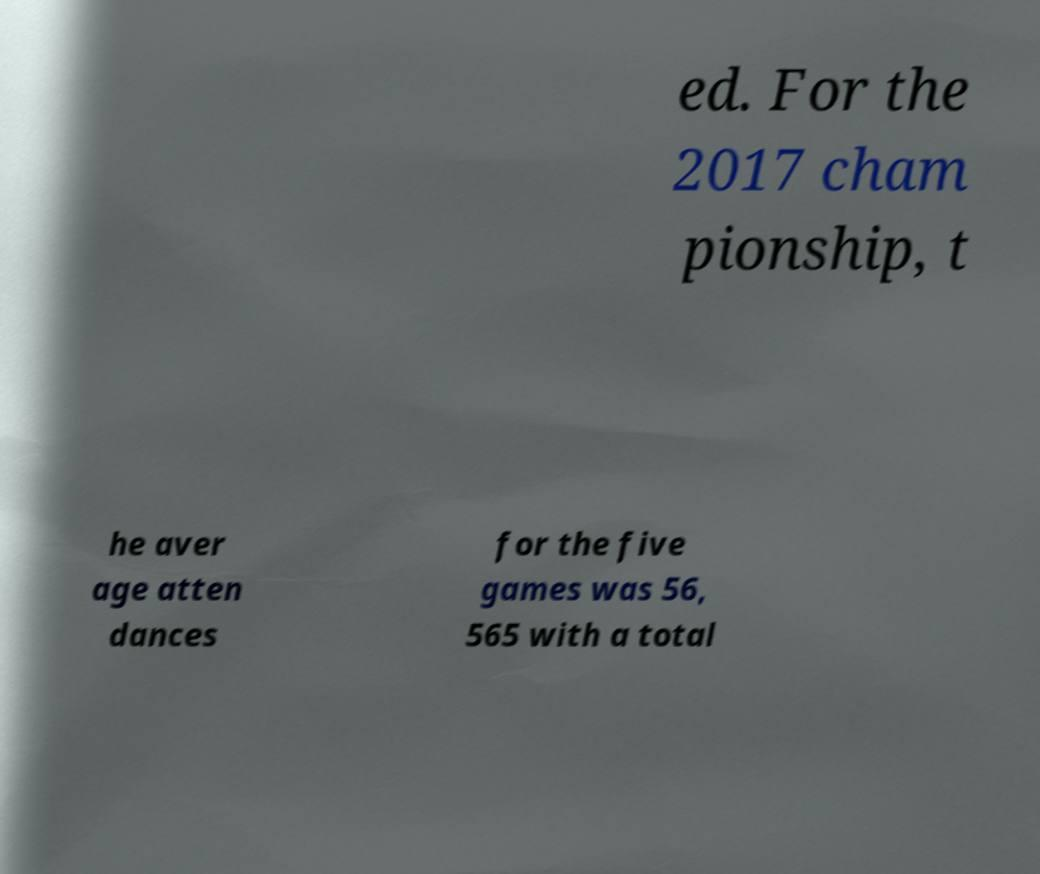I need the written content from this picture converted into text. Can you do that? ed. For the 2017 cham pionship, t he aver age atten dances for the five games was 56, 565 with a total 